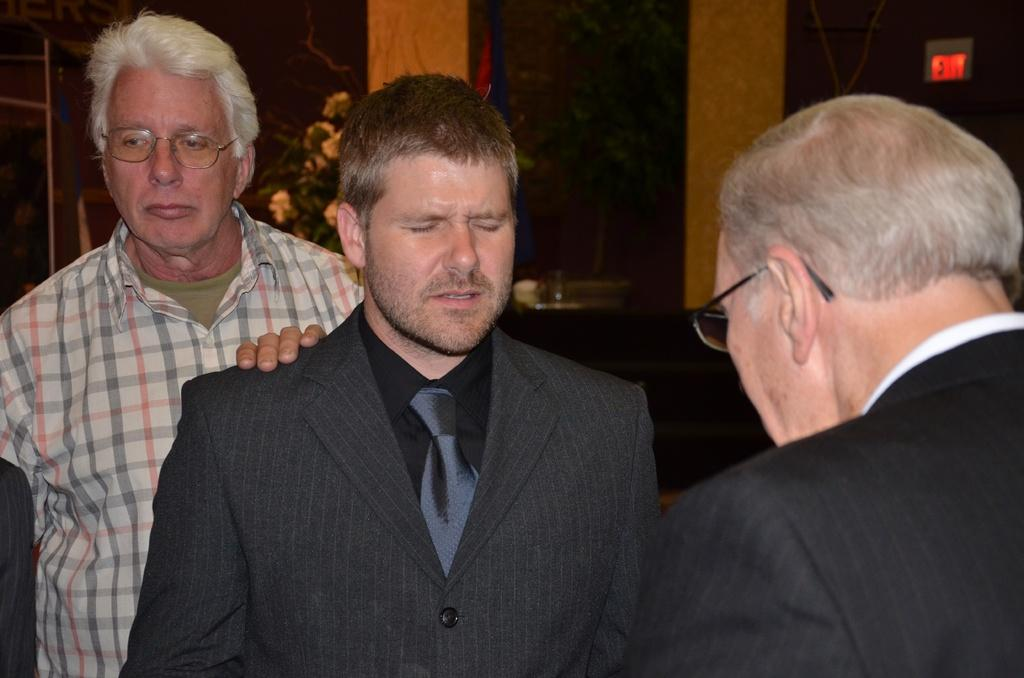How many people are present in the image? There are three men standing in the image. What can be seen on the backside of the image? There is a plant in a pot on the backside of the image. What type of structure is visible in the image? There is a wall visible in the image. What is the purpose of the signboard in the image? The purpose of the signboard in the image is to convey information or provide directions. What type of metal is used to make the crack in the image? There is no crack present in the image, and therefore no metal can be associated with it. 